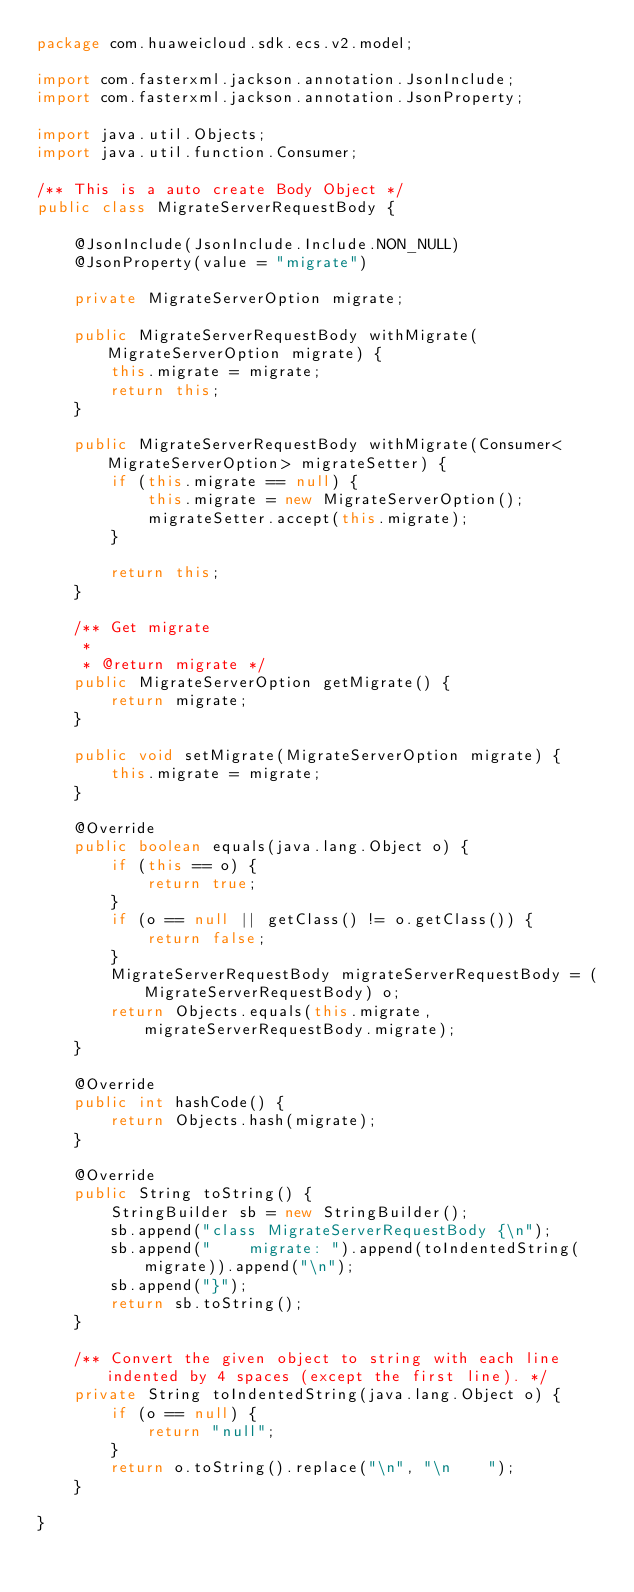<code> <loc_0><loc_0><loc_500><loc_500><_Java_>package com.huaweicloud.sdk.ecs.v2.model;

import com.fasterxml.jackson.annotation.JsonInclude;
import com.fasterxml.jackson.annotation.JsonProperty;

import java.util.Objects;
import java.util.function.Consumer;

/** This is a auto create Body Object */
public class MigrateServerRequestBody {

    @JsonInclude(JsonInclude.Include.NON_NULL)
    @JsonProperty(value = "migrate")

    private MigrateServerOption migrate;

    public MigrateServerRequestBody withMigrate(MigrateServerOption migrate) {
        this.migrate = migrate;
        return this;
    }

    public MigrateServerRequestBody withMigrate(Consumer<MigrateServerOption> migrateSetter) {
        if (this.migrate == null) {
            this.migrate = new MigrateServerOption();
            migrateSetter.accept(this.migrate);
        }

        return this;
    }

    /** Get migrate
     * 
     * @return migrate */
    public MigrateServerOption getMigrate() {
        return migrate;
    }

    public void setMigrate(MigrateServerOption migrate) {
        this.migrate = migrate;
    }

    @Override
    public boolean equals(java.lang.Object o) {
        if (this == o) {
            return true;
        }
        if (o == null || getClass() != o.getClass()) {
            return false;
        }
        MigrateServerRequestBody migrateServerRequestBody = (MigrateServerRequestBody) o;
        return Objects.equals(this.migrate, migrateServerRequestBody.migrate);
    }

    @Override
    public int hashCode() {
        return Objects.hash(migrate);
    }

    @Override
    public String toString() {
        StringBuilder sb = new StringBuilder();
        sb.append("class MigrateServerRequestBody {\n");
        sb.append("    migrate: ").append(toIndentedString(migrate)).append("\n");
        sb.append("}");
        return sb.toString();
    }

    /** Convert the given object to string with each line indented by 4 spaces (except the first line). */
    private String toIndentedString(java.lang.Object o) {
        if (o == null) {
            return "null";
        }
        return o.toString().replace("\n", "\n    ");
    }

}
</code> 